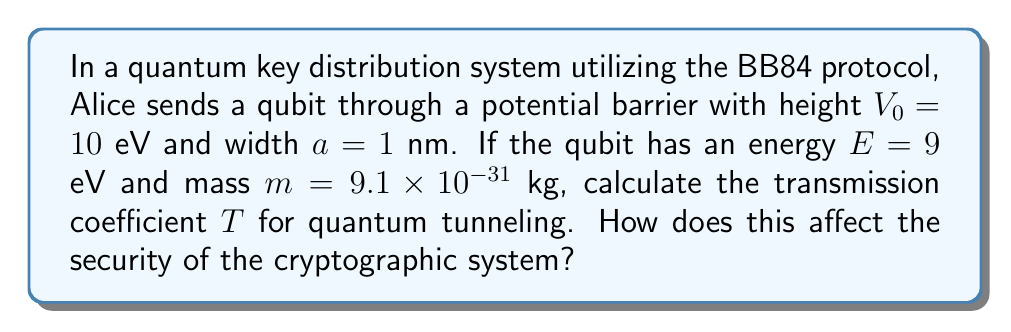Help me with this question. To solve this problem, we'll follow these steps:

1) The transmission coefficient for quantum tunneling through a rectangular barrier is given by:

   $$T \approx e^{-2ka}$$

   where $k$ is the wave number inside the barrier.

2) The wave number $k$ is given by:

   $$k = \sqrt{\frac{2m(V_0 - E)}{\hbar^2}}$$

3) Let's calculate $k$:
   
   $$k = \sqrt{\frac{2(9.1 \times 10^{-31})(10 - 9)(1.6 \times 10^{-19})}{(1.05 \times 10^{-34})^2}}$$

4) Simplifying:

   $$k = \sqrt{\frac{2.912 \times 10^{-49}}{1.1025 \times 10^{-68}}} = 5.14 \times 10^9 \text{ m}^{-1}$$

5) Now we can calculate $T$:

   $$T \approx e^{-2(5.14 \times 10^9)(1 \times 10^{-9})} = e^{-10.28} \approx 3.43 \times 10^{-5}$$

6) This means that about 0.00343% of qubits will tunnel through the barrier.

7) In terms of cryptographic security, this tunneling effect introduces a small but non-zero probability of qubits being detected even when they shouldn't pass through the barrier. This could potentially lead to errors in the key distribution process.

8) However, the BB84 protocol is designed to be robust against such errors. The small transmission coefficient means that the error rate introduced by tunneling is likely to be well below the threshold at which the key distribution would be considered compromised (typically around 11%).

9) Nevertheless, in a high-security environment, this tunneling effect should be accounted for in the error correction and privacy amplification stages of the protocol to ensure the integrity of the final key.
Answer: $T \approx 3.43 \times 10^{-5}$; introduces small error rate, manageable with BB84 protocol 